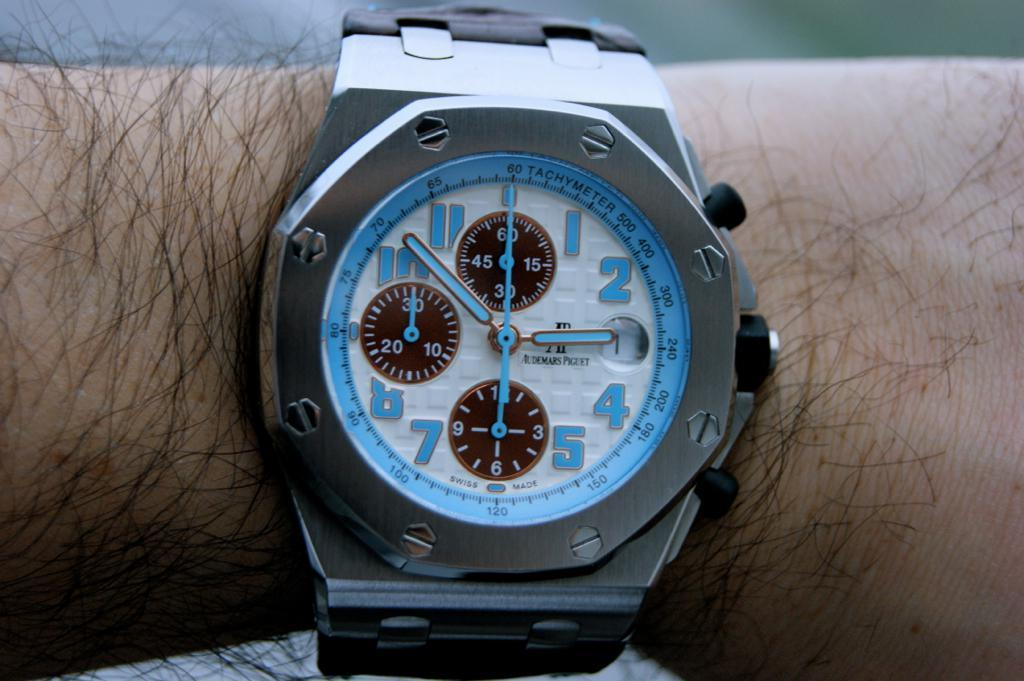<image>
Give a short and clear explanation of the subsequent image. the number 2 is on the watch in blue 